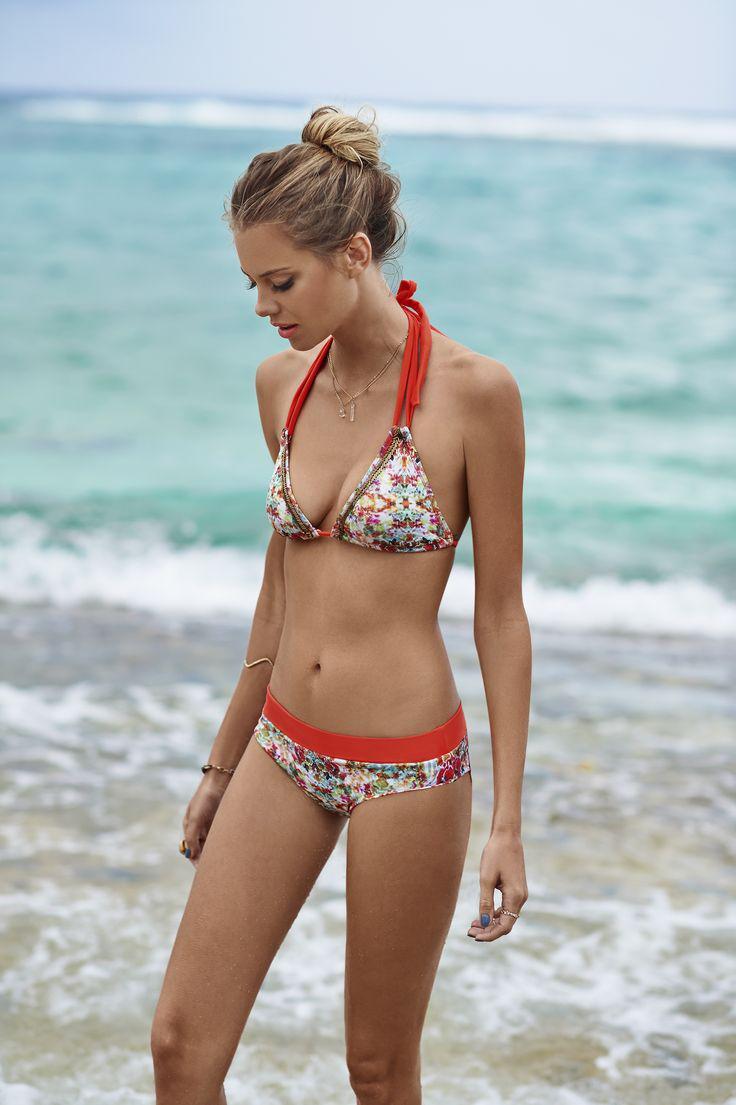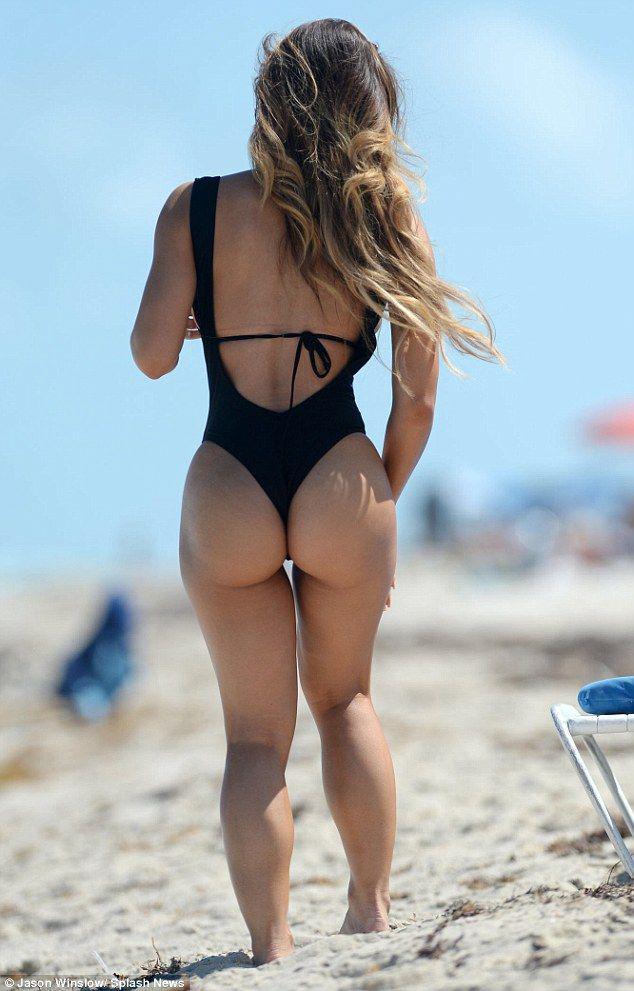The first image is the image on the left, the second image is the image on the right. Given the left and right images, does the statement "There are three women at the beach." hold true? Answer yes or no. No. The first image is the image on the left, the second image is the image on the right. Examine the images to the left and right. Is the description "In 1 of the images, 1 girl with a pink bikini and 1 girl with a green bikini is sitting." accurate? Answer yes or no. No. 